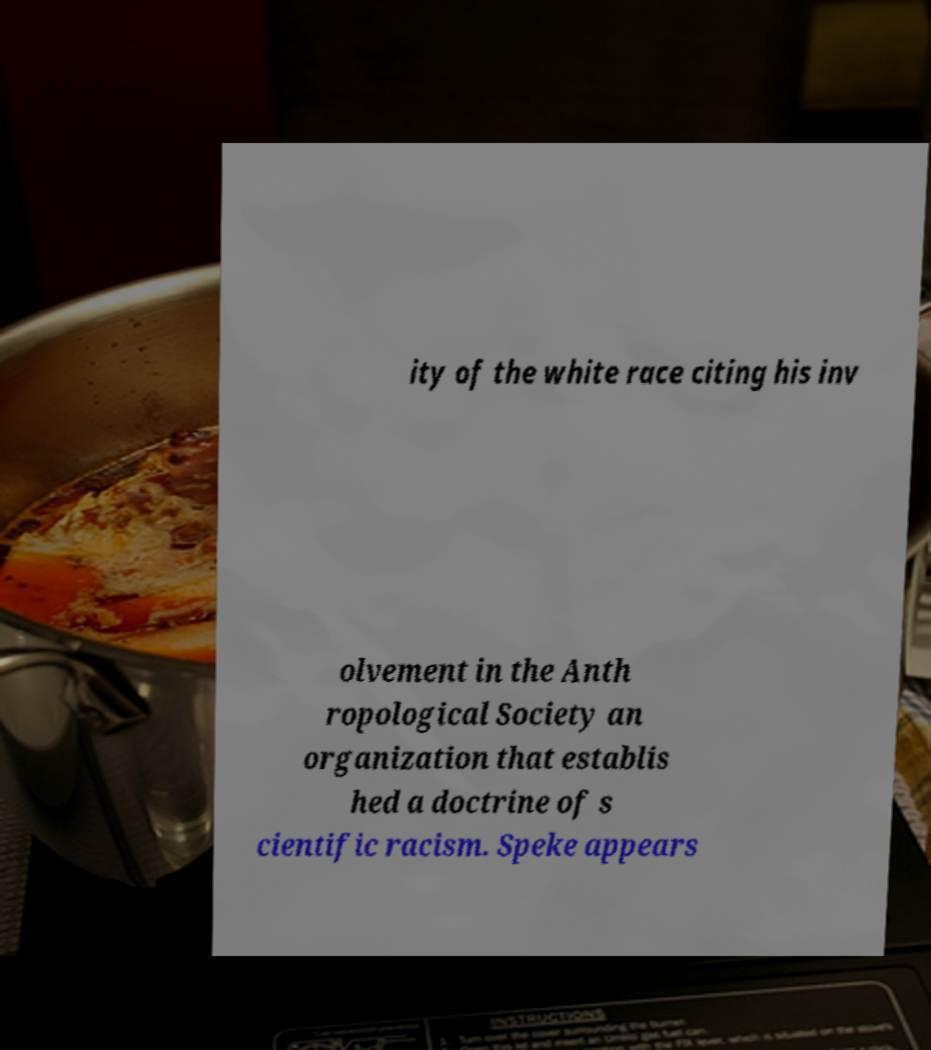What messages or text are displayed in this image? I need them in a readable, typed format. ity of the white race citing his inv olvement in the Anth ropological Society an organization that establis hed a doctrine of s cientific racism. Speke appears 